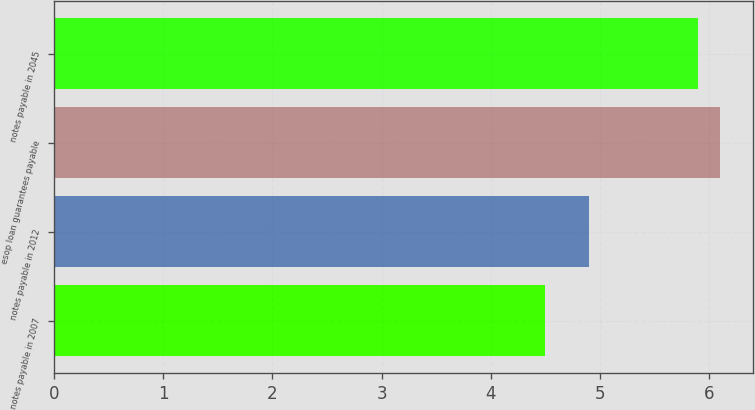Convert chart to OTSL. <chart><loc_0><loc_0><loc_500><loc_500><bar_chart><fcel>notes payable in 2007<fcel>notes payable in 2012<fcel>esop loan guarantees payable<fcel>notes payable in 2045<nl><fcel>4.5<fcel>4.9<fcel>6.1<fcel>5.9<nl></chart> 